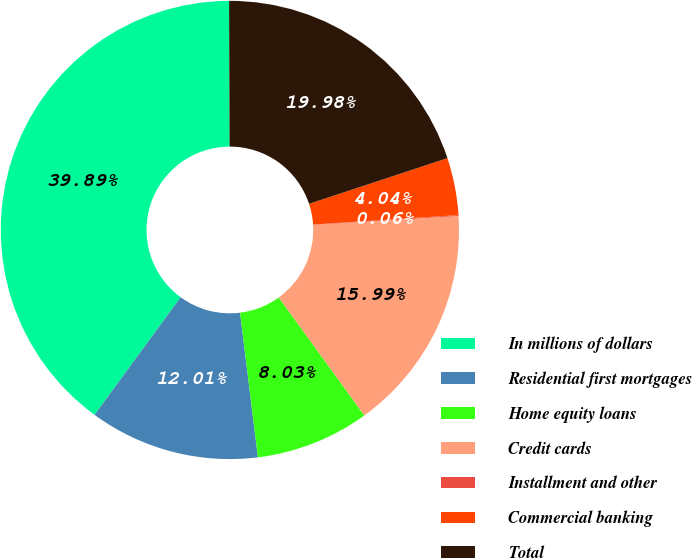<chart> <loc_0><loc_0><loc_500><loc_500><pie_chart><fcel>In millions of dollars<fcel>Residential first mortgages<fcel>Home equity loans<fcel>Credit cards<fcel>Installment and other<fcel>Commercial banking<fcel>Total<nl><fcel>39.89%<fcel>12.01%<fcel>8.03%<fcel>15.99%<fcel>0.06%<fcel>4.04%<fcel>19.98%<nl></chart> 